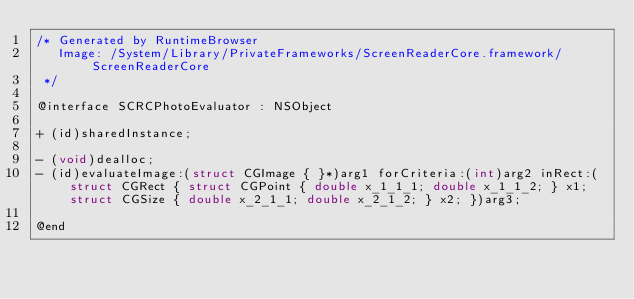<code> <loc_0><loc_0><loc_500><loc_500><_C_>/* Generated by RuntimeBrowser
   Image: /System/Library/PrivateFrameworks/ScreenReaderCore.framework/ScreenReaderCore
 */

@interface SCRCPhotoEvaluator : NSObject

+ (id)sharedInstance;

- (void)dealloc;
- (id)evaluateImage:(struct CGImage { }*)arg1 forCriteria:(int)arg2 inRect:(struct CGRect { struct CGPoint { double x_1_1_1; double x_1_1_2; } x1; struct CGSize { double x_2_1_1; double x_2_1_2; } x2; })arg3;

@end
</code> 